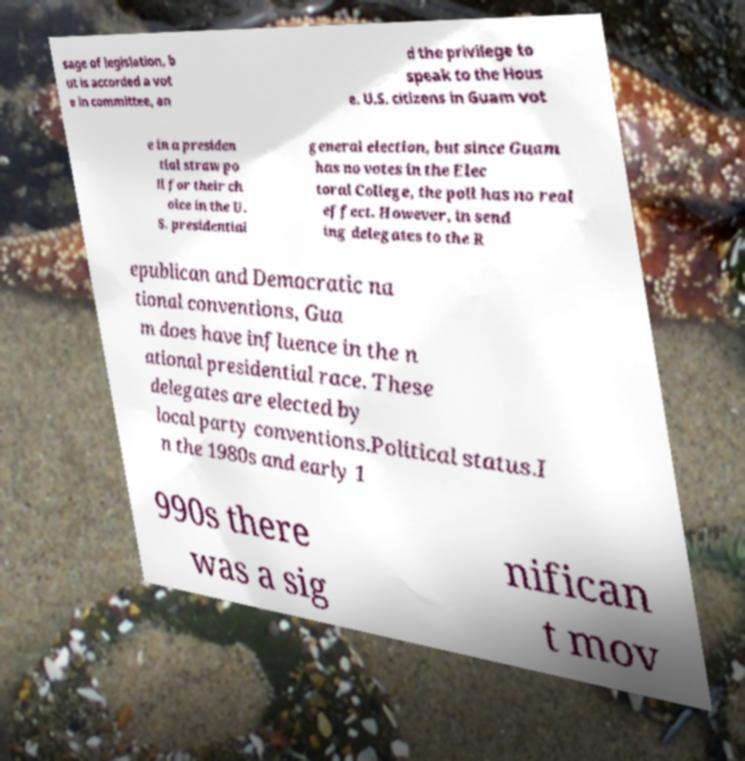Could you extract and type out the text from this image? sage of legislation, b ut is accorded a vot e in committee, an d the privilege to speak to the Hous e. U.S. citizens in Guam vot e in a presiden tial straw po ll for their ch oice in the U. S. presidential general election, but since Guam has no votes in the Elec toral College, the poll has no real effect. However, in send ing delegates to the R epublican and Democratic na tional conventions, Gua m does have influence in the n ational presidential race. These delegates are elected by local party conventions.Political status.I n the 1980s and early 1 990s there was a sig nifican t mov 